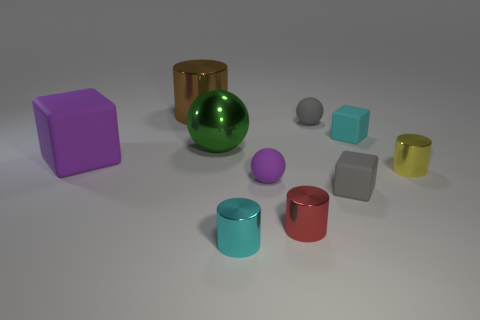Can you describe the arrangement and the materials of the objects in the image? Certainly! The image shows a collection of geometric shapes arranged on a flat surface. In the center, there's a large shiny green ball, which is most likely made of glass or polished metal due to its reflective surface. Scattered around the ball are various other objects: a purple cube, a cyan metal cylinder, a red metal cylinder, a gray metal cylinder, two smaller balls—one purple and one gray—along with yellow and lime green transparent cylinders towards the back. The arrangement appears to be random, with each item casting a soft shadow, indicating a diffuse lighting source above. 